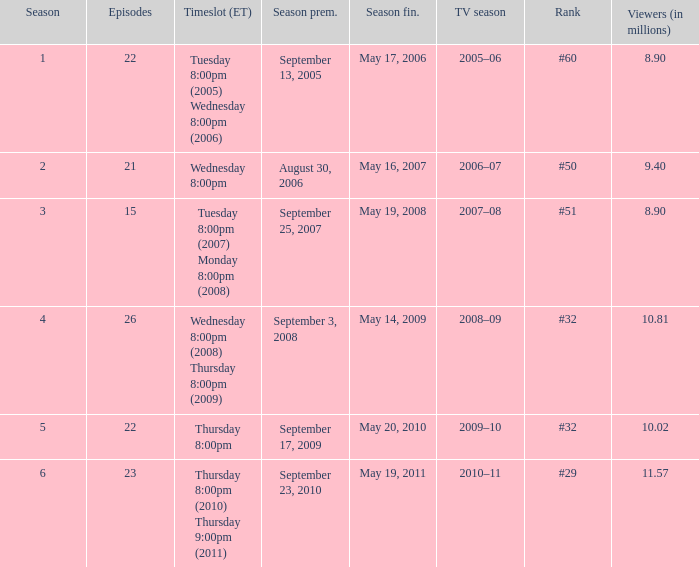What tv season was episode 23 broadcast? 2010–11. 